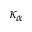<formula> <loc_0><loc_0><loc_500><loc_500>\kappa _ { \alpha }</formula> 